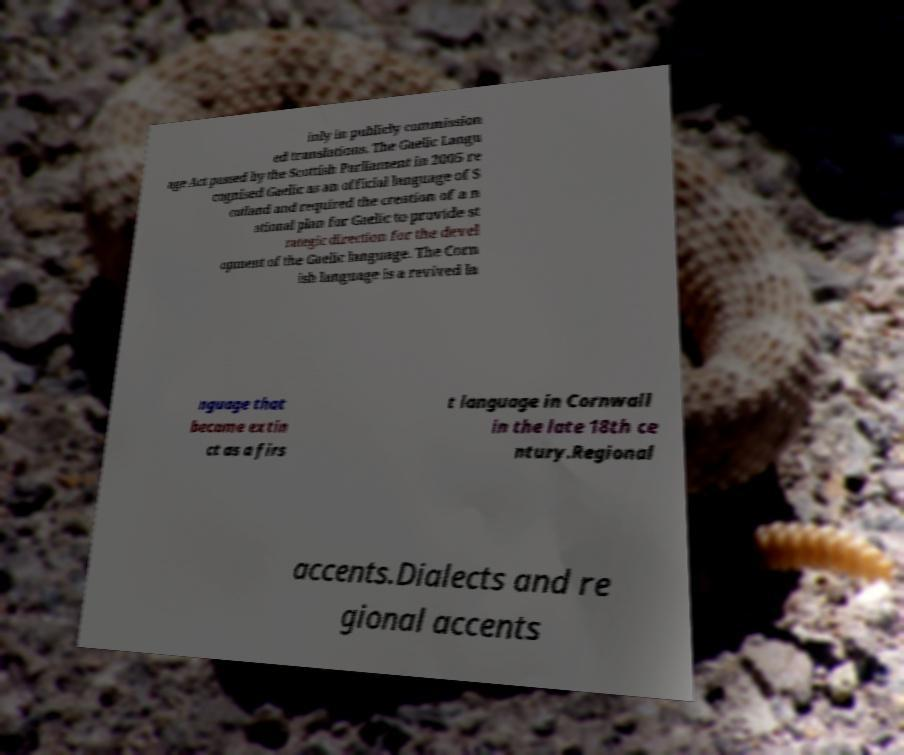For documentation purposes, I need the text within this image transcribed. Could you provide that? inly in publicly commission ed translations. The Gaelic Langu age Act passed by the Scottish Parliament in 2005 re cognised Gaelic as an official language of S cotland and required the creation of a n ational plan for Gaelic to provide st rategic direction for the devel opment of the Gaelic language. The Corn ish language is a revived la nguage that became extin ct as a firs t language in Cornwall in the late 18th ce ntury.Regional accents.Dialects and re gional accents 